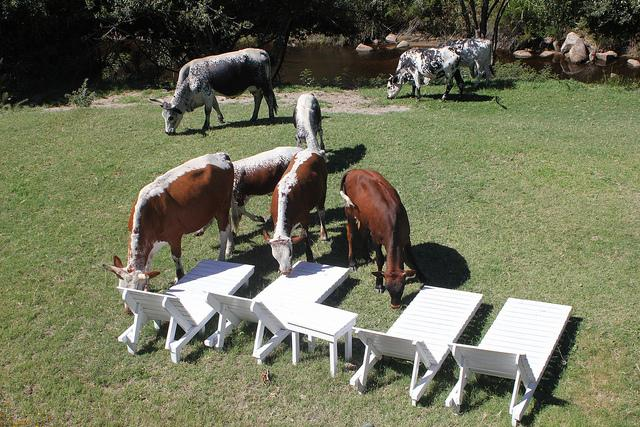What are the animals near?

Choices:
A) cars
B) apple trees
C) baby carriages
D) chairs chairs 